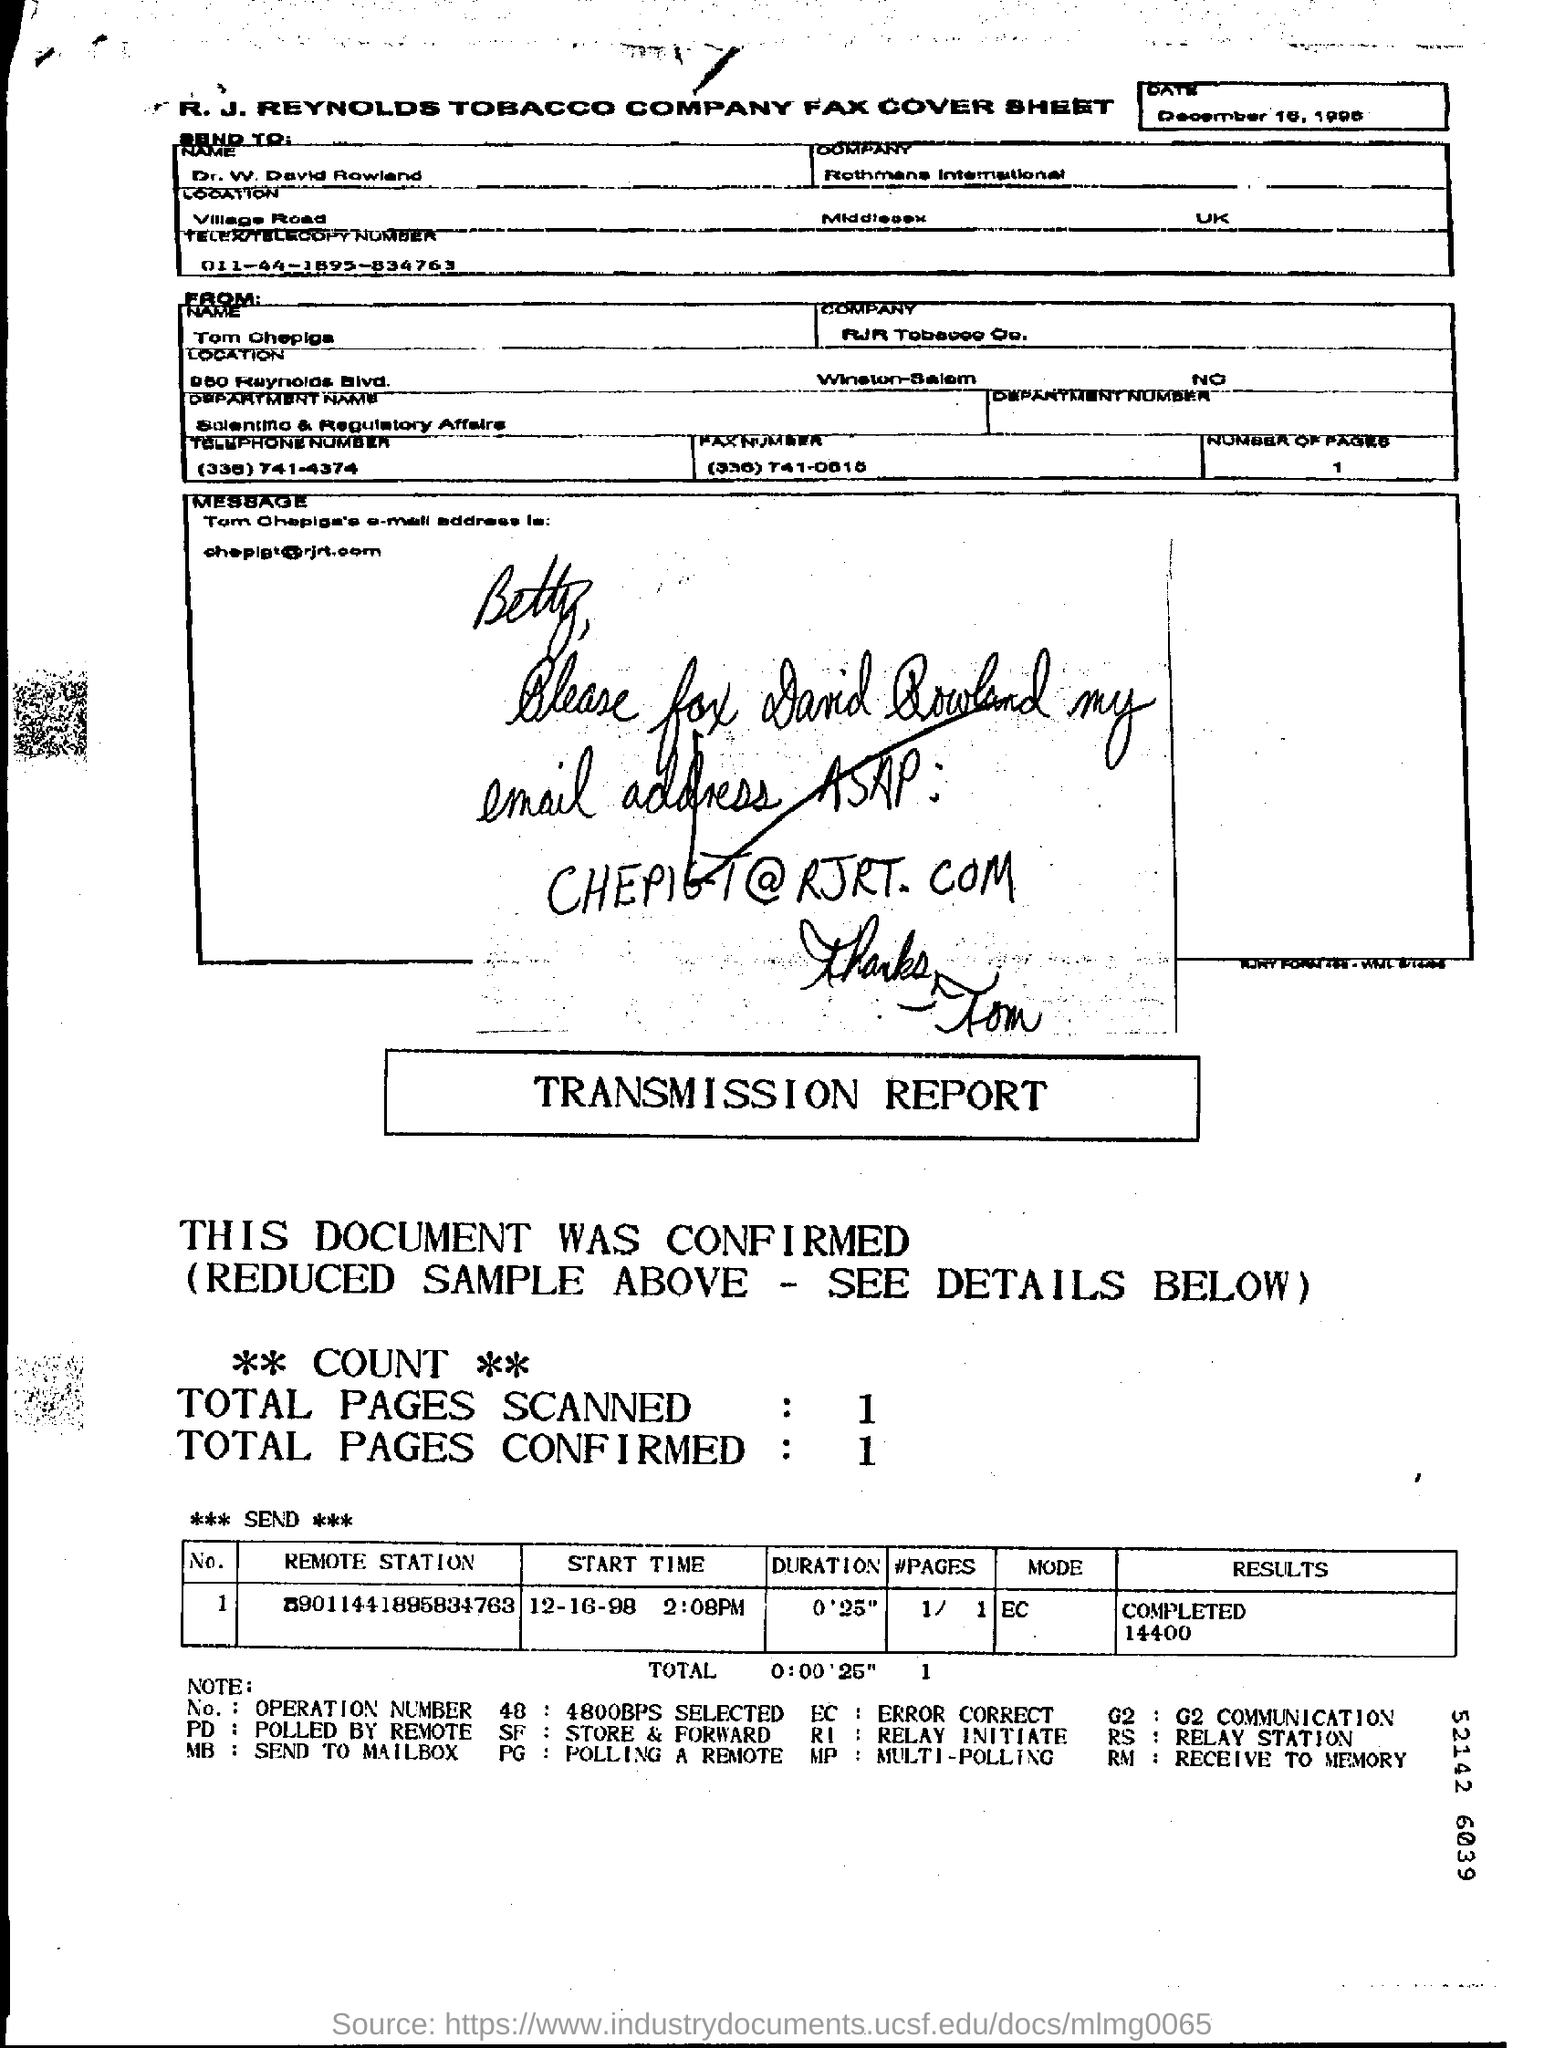What is the Send To "Name"?
Your response must be concise. Dr. W. David Rowland. Which company is the sender associated with?
Offer a terse response. Rothmans International. Who is this Fax from?
Your response must be concise. Tom Ohepiga. What is the "Duration"?
Give a very brief answer. 0'25". What is the "Start Time"?
Your answer should be compact. 12-16-98 2:08PM. What are the "Results"?
Make the answer very short. Completed 14400. What are the Total Pages Scanned?
Keep it short and to the point. 1. What are the Total Pages Confirmed?
Your response must be concise. 1. 